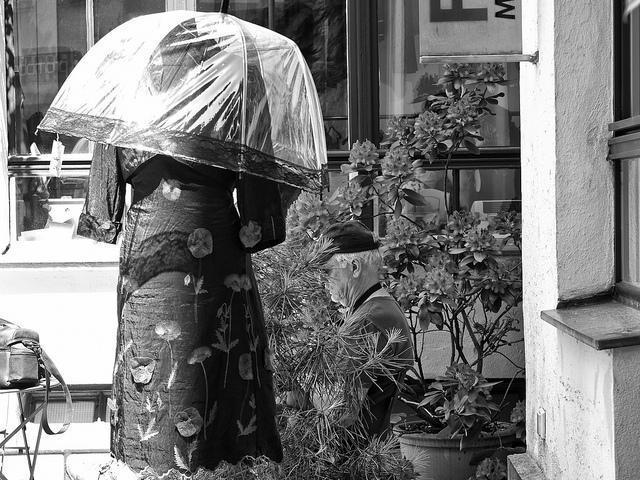How many people are shown?
Give a very brief answer. 2. How many people can be seen?
Give a very brief answer. 2. How many chairs have a checkered pattern?
Give a very brief answer. 0. 